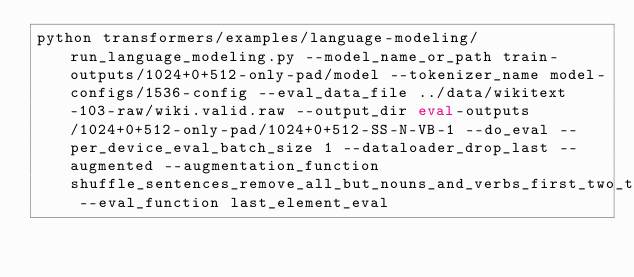<code> <loc_0><loc_0><loc_500><loc_500><_Bash_>python transformers/examples/language-modeling/run_language_modeling.py --model_name_or_path train-outputs/1024+0+512-only-pad/model --tokenizer_name model-configs/1536-config --eval_data_file ../data/wikitext-103-raw/wiki.valid.raw --output_dir eval-outputs/1024+0+512-only-pad/1024+0+512-SS-N-VB-1 --do_eval --per_device_eval_batch_size 1 --dataloader_drop_last --augmented --augmentation_function shuffle_sentences_remove_all_but_nouns_and_verbs_first_two_thirds_full --eval_function last_element_eval</code> 